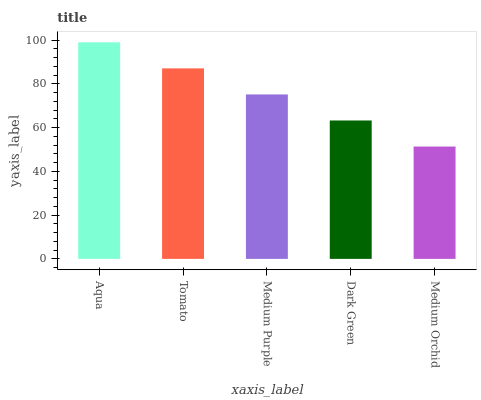Is Tomato the minimum?
Answer yes or no. No. Is Tomato the maximum?
Answer yes or no. No. Is Aqua greater than Tomato?
Answer yes or no. Yes. Is Tomato less than Aqua?
Answer yes or no. Yes. Is Tomato greater than Aqua?
Answer yes or no. No. Is Aqua less than Tomato?
Answer yes or no. No. Is Medium Purple the high median?
Answer yes or no. Yes. Is Medium Purple the low median?
Answer yes or no. Yes. Is Dark Green the high median?
Answer yes or no. No. Is Dark Green the low median?
Answer yes or no. No. 